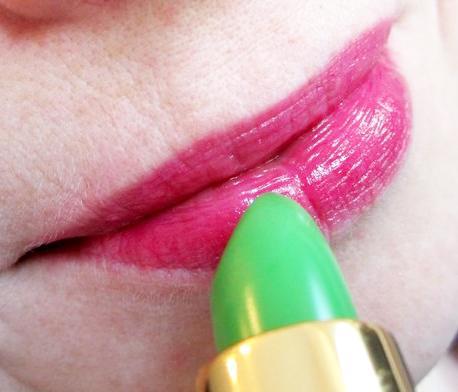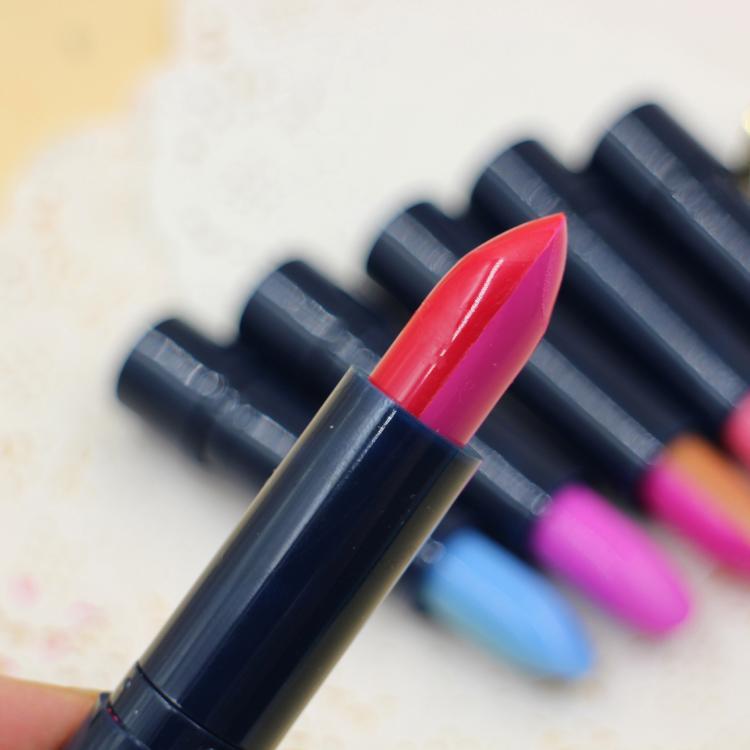The first image is the image on the left, the second image is the image on the right. Examine the images to the left and right. Is the description "An image shows a lipstick by colored lips." accurate? Answer yes or no. Yes. 